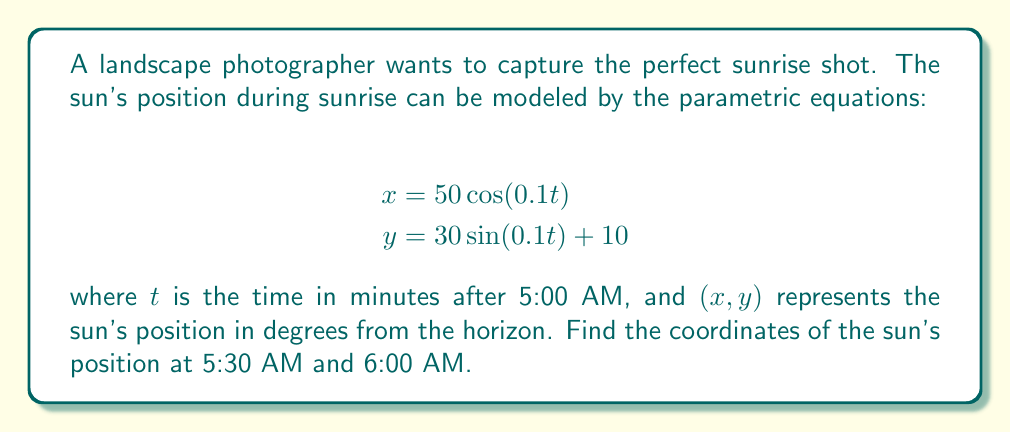Can you answer this question? To solve this problem, we need to follow these steps:

1. Determine the value of $t$ for each time:
   - At 5:30 AM, 30 minutes have passed, so $t = 30$
   - At 6:00 AM, 60 minutes have passed, so $t = 60$

2. Calculate the x-coordinate for 5:30 AM:
   $$x = 50\cos(0.1 \cdot 30) = 50\cos(3) \approx 0.4161$$

3. Calculate the y-coordinate for 5:30 AM:
   $$y = 30\sin(0.1 \cdot 30) + 10 = 30\sin(3) + 10 \approx 24.1201$$

4. Calculate the x-coordinate for 6:00 AM:
   $$x = 50\cos(0.1 \cdot 60) = 50\cos(6) \approx -47.6314$$

5. Calculate the y-coordinate for 6:00 AM:
   $$y = 30\sin(0.1 \cdot 60) + 10 = 30\sin(6) + 10 \approx 18.7185$$

6. Round the results to two decimal places for practical use in photography.

[asy]
import geometry;

size(200);
draw((-50,0)--(50,0),arrow=Arrow(TeXHead));
draw((0,0)--(0,40),arrow=Arrow(TeXHead));
label("x",(50,0),E);
label("y",(0,40),N);
dot((0.42,24.12),red);
dot((-47.63,18.72),blue);
label("5:30 AM",(0.42,24.12),NE,red);
label("6:00 AM",(-47.63,18.72),NW,blue);
[/asy]
Answer: (0.42, 24.12) at 5:30 AM; (-47.63, 18.72) at 6:00 AM 